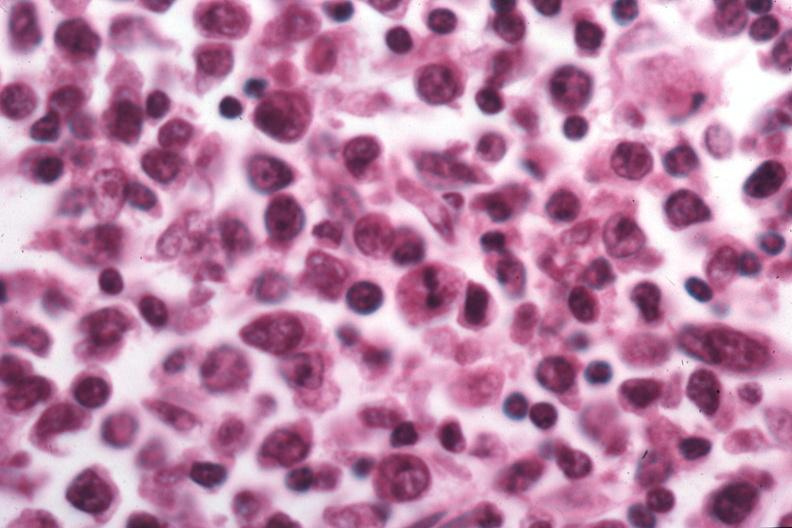what is present?
Answer the question using a single word or phrase. Malignant lymphoma 